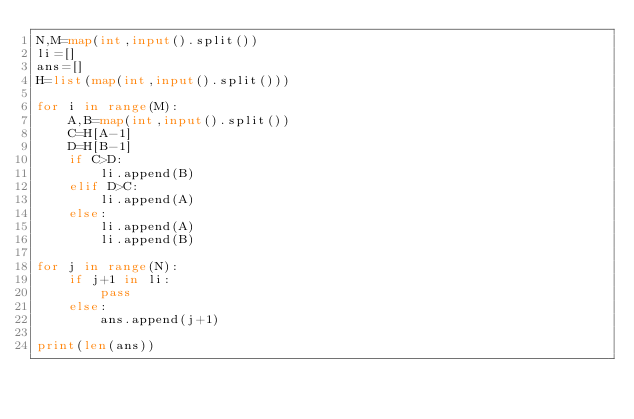Convert code to text. <code><loc_0><loc_0><loc_500><loc_500><_Python_>N,M=map(int,input().split())
li=[]
ans=[]
H=list(map(int,input().split()))

for i in range(M):
    A,B=map(int,input().split())
    C=H[A-1]
    D=H[B-1]
    if C>D:
        li.append(B)
    elif D>C:
        li.append(A)
    else:
        li.append(A)
        li.append(B)

for j in range(N):
    if j+1 in li:
        pass
    else:
        ans.append(j+1)

print(len(ans))
</code> 